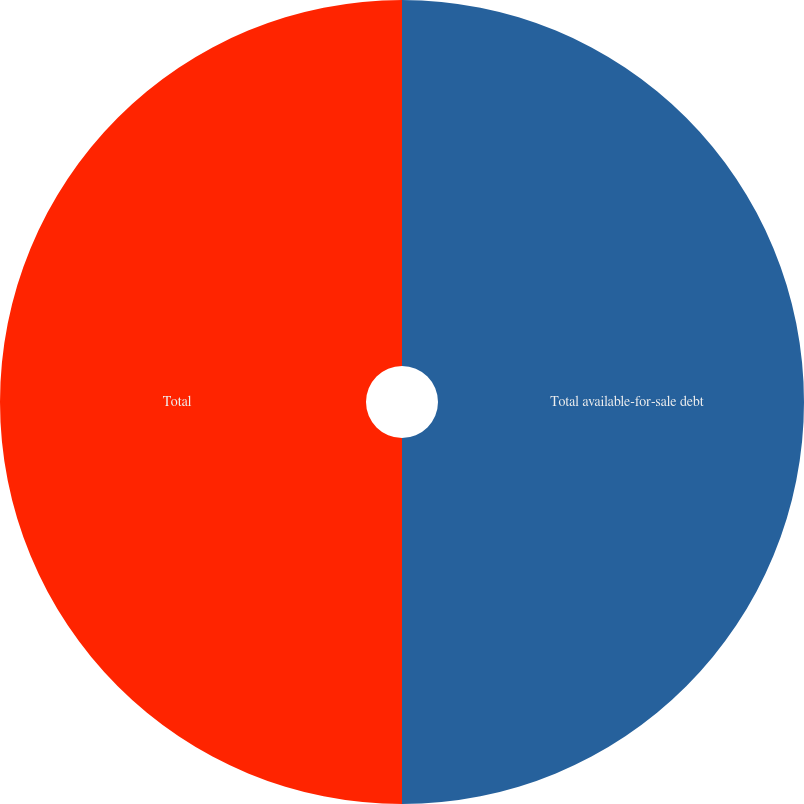<chart> <loc_0><loc_0><loc_500><loc_500><pie_chart><fcel>Total available-for-sale debt<fcel>Total<nl><fcel>50.0%<fcel>50.0%<nl></chart> 